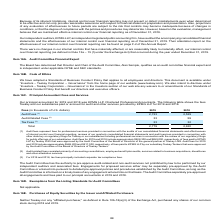According to Teekay Corporation's financial document, Who was the principal accountant for 2019 and 2018? KPMG LLP, Chartered Professional Accountants.. The document states: "Our principal accountant for 2019 and 2018 was KPMG LLP, Chartered Professional Accountants. The following table shows the fees Teekay and our subsidi..." Also, What fees was paid to KPMG LLP by Teekay Tankers during 2019 and 2018 respectively? The document shows two values: $588,200 and $517,000. From the document: "r 2019 and 2018 include approximately $588,200 and $517,000, respectively, of fees paid to KPMG LLP by our subsidiary Teekay Tankers that were approve..." Also, What fees was paid to KPMG LLP by Teekay LNG during 2019 and 2018? The document shows two values: $928,300 and $859,000. From the document: "r 2019 and 2018 include approximately $928,300 and $859,000, respectively, of fees paid to KPMG LLP by Teekay LNG that were approved by the Audit Comm..." Also, can you calculate: What is the change in Audit Fees from 2019 to 2018? Based on the calculation: 2,723-2,529, the result is 194 (in thousands). This is based on the information: "Audit Fees (1) 2,723 2,529 Audit Fees (1) 2,723 2,529..." The key data points involved are: 2,529, 2,723. Also, can you calculate: What is the change in Audit-Related Fees from 2019 to 2018? Based on the calculation: 33-59, the result is -26 (in thousands). This is based on the information: "Audit-Related Fees (2) 33 59 Audit-Related Fees (2) 33 59..." The key data points involved are: 33, 59. Also, can you calculate: What is the change in Tax Fees from 2019 to 2018? Based on the calculation: 23-32, the result is -9 (in thousands). This is based on the information: "Tax Fees (3) 23 32 Tax Fees (3) 23 32..." The key data points involved are: 23, 32. 